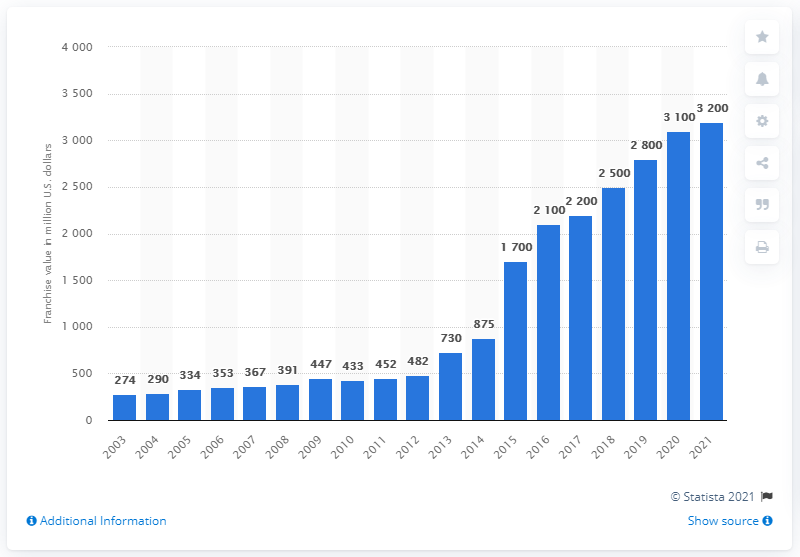Point out several critical features in this image. The estimated value of the Boston Celtics franchise in 2021 was approximately 3,200 dollars. 